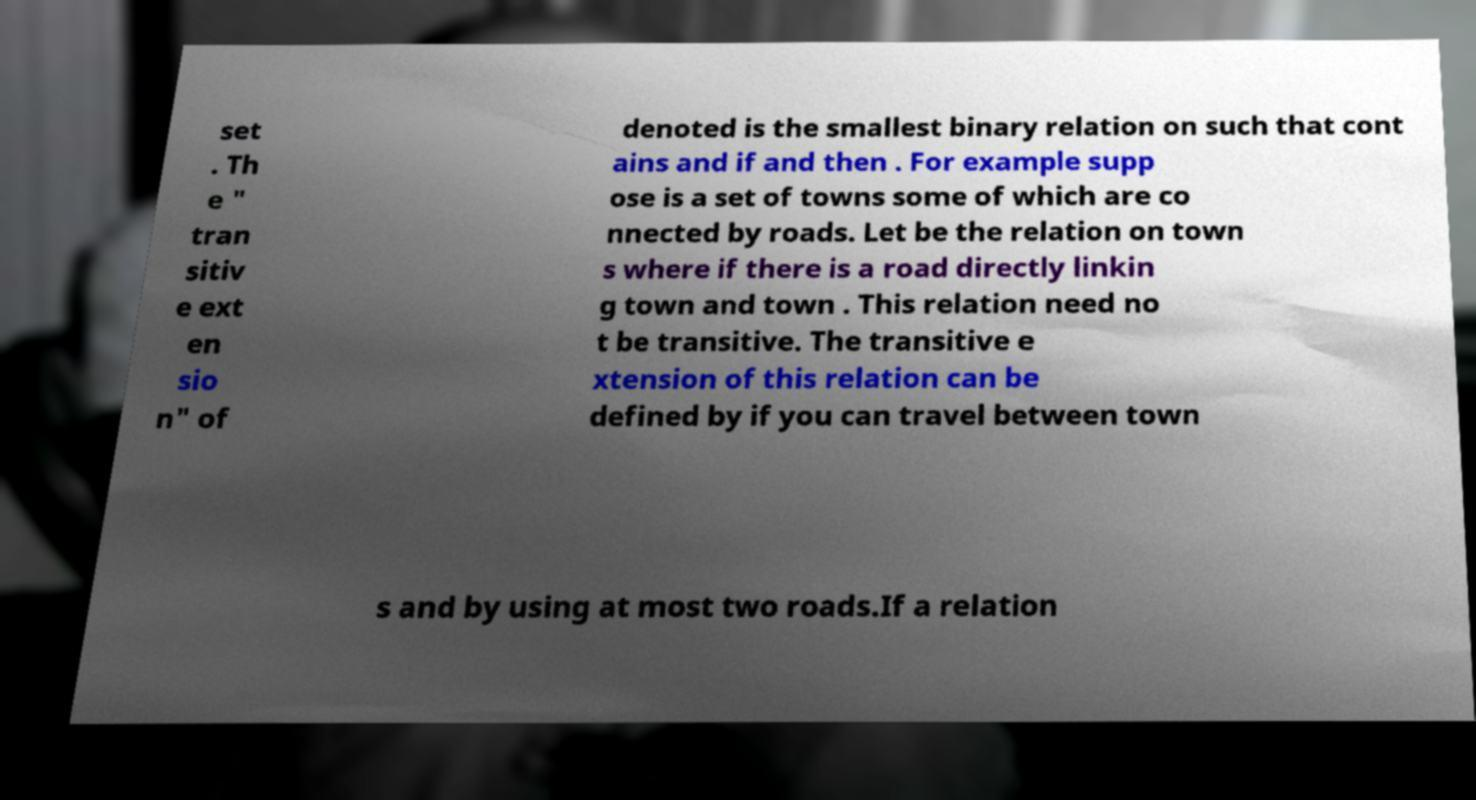Could you assist in decoding the text presented in this image and type it out clearly? set . Th e " tran sitiv e ext en sio n" of denoted is the smallest binary relation on such that cont ains and if and then . For example supp ose is a set of towns some of which are co nnected by roads. Let be the relation on town s where if there is a road directly linkin g town and town . This relation need no t be transitive. The transitive e xtension of this relation can be defined by if you can travel between town s and by using at most two roads.If a relation 